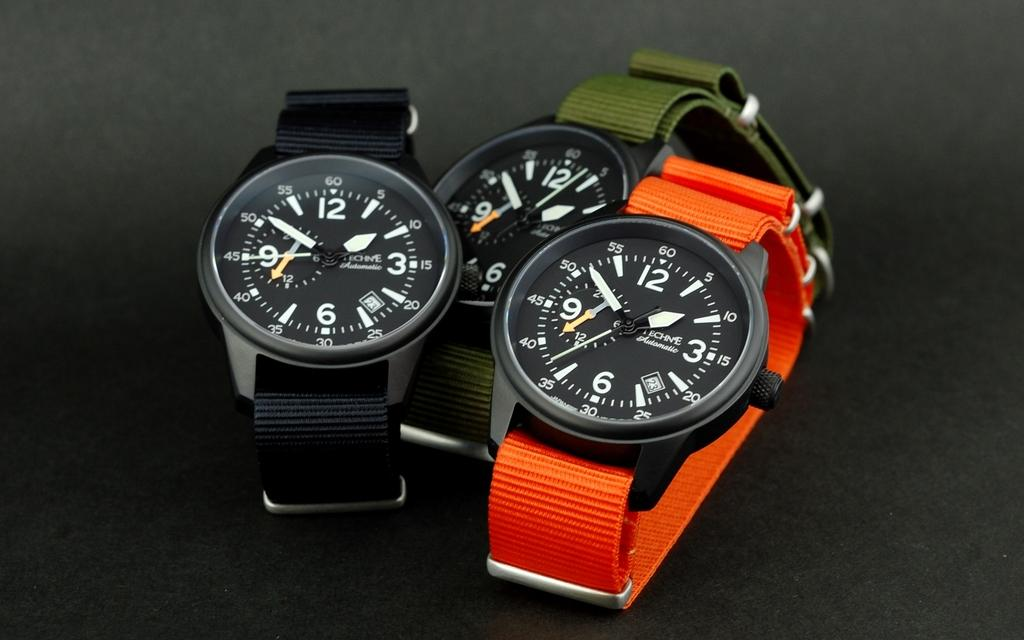<image>
Describe the image concisely. Three watches of the same style are all displaying the time ten to two. 